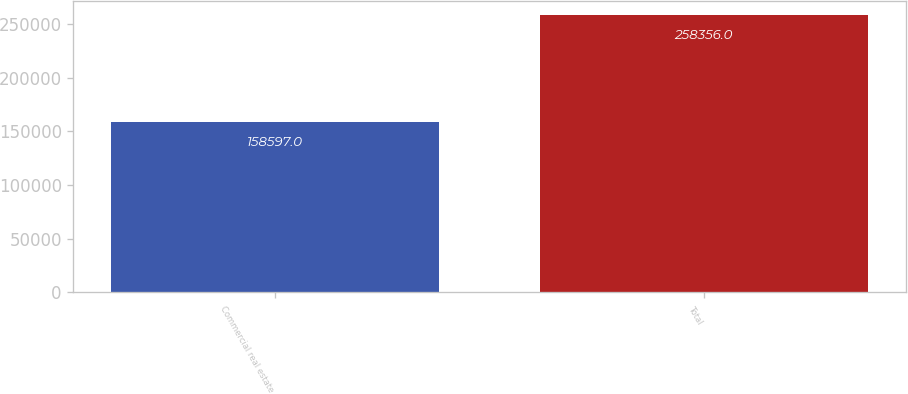Convert chart. <chart><loc_0><loc_0><loc_500><loc_500><bar_chart><fcel>Commercial real estate<fcel>Total<nl><fcel>158597<fcel>258356<nl></chart> 